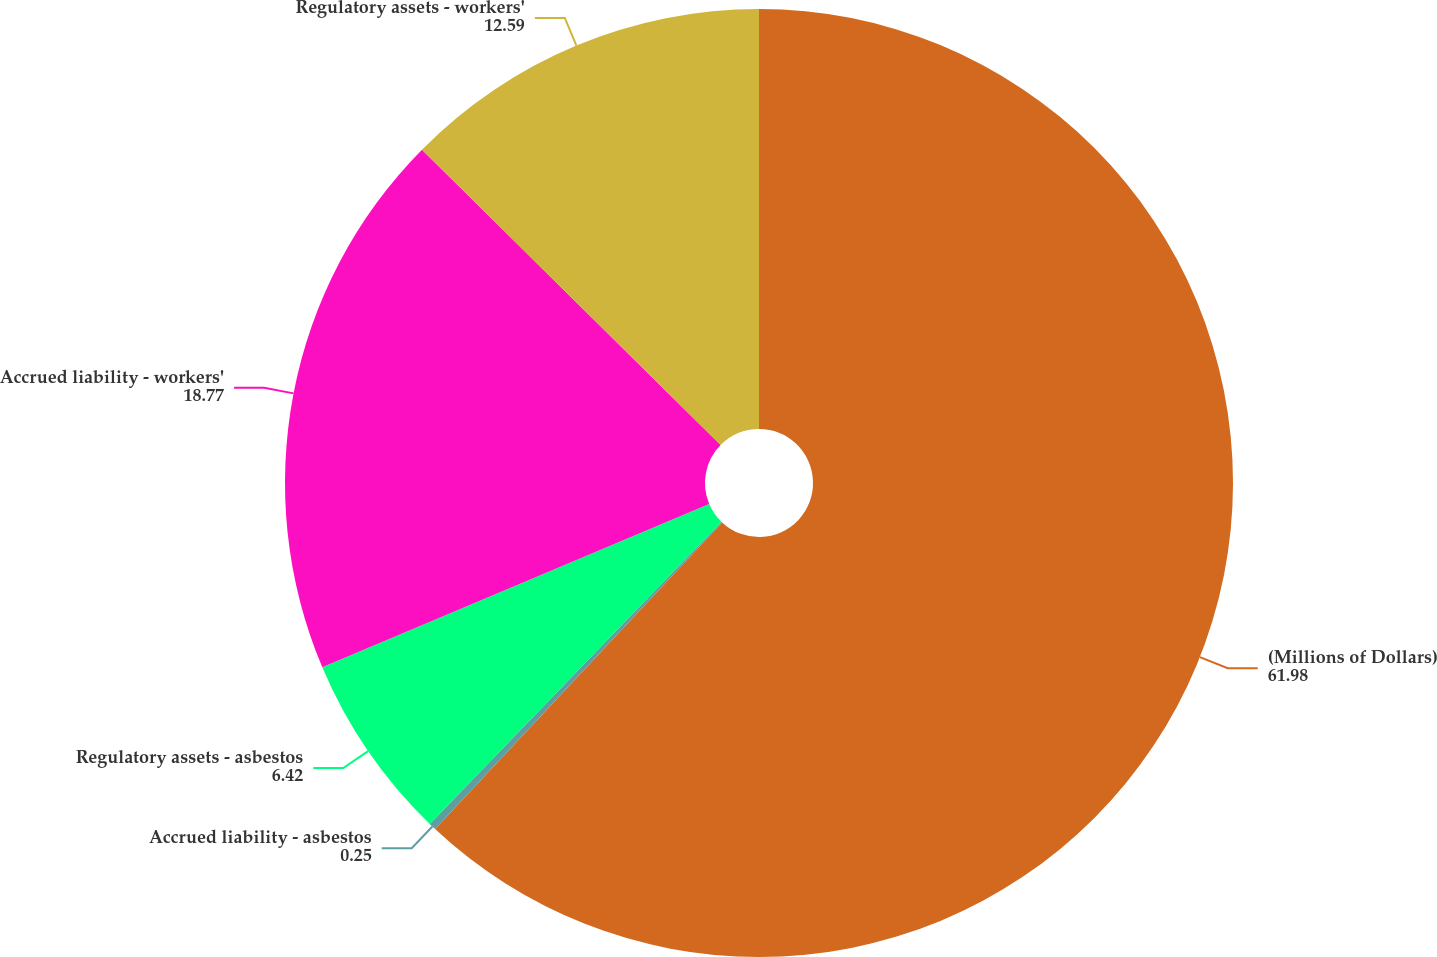<chart> <loc_0><loc_0><loc_500><loc_500><pie_chart><fcel>(Millions of Dollars)<fcel>Accrued liability - asbestos<fcel>Regulatory assets - asbestos<fcel>Accrued liability - workers'<fcel>Regulatory assets - workers'<nl><fcel>61.98%<fcel>0.25%<fcel>6.42%<fcel>18.77%<fcel>12.59%<nl></chart> 